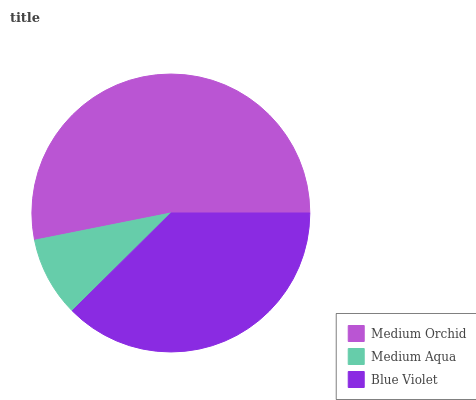Is Medium Aqua the minimum?
Answer yes or no. Yes. Is Medium Orchid the maximum?
Answer yes or no. Yes. Is Blue Violet the minimum?
Answer yes or no. No. Is Blue Violet the maximum?
Answer yes or no. No. Is Blue Violet greater than Medium Aqua?
Answer yes or no. Yes. Is Medium Aqua less than Blue Violet?
Answer yes or no. Yes. Is Medium Aqua greater than Blue Violet?
Answer yes or no. No. Is Blue Violet less than Medium Aqua?
Answer yes or no. No. Is Blue Violet the high median?
Answer yes or no. Yes. Is Blue Violet the low median?
Answer yes or no. Yes. Is Medium Orchid the high median?
Answer yes or no. No. Is Medium Aqua the low median?
Answer yes or no. No. 